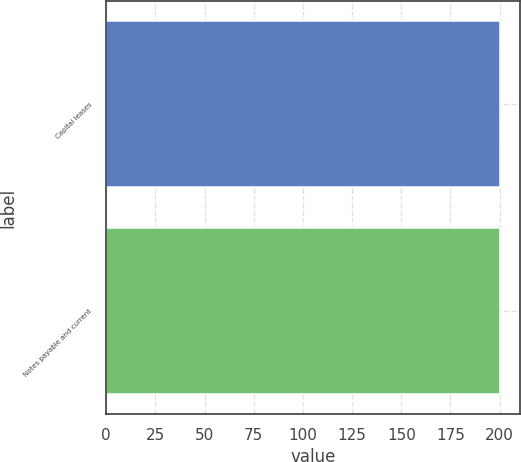<chart> <loc_0><loc_0><loc_500><loc_500><bar_chart><fcel>Capital leases<fcel>Notes payable and current<nl><fcel>200<fcel>200.1<nl></chart> 